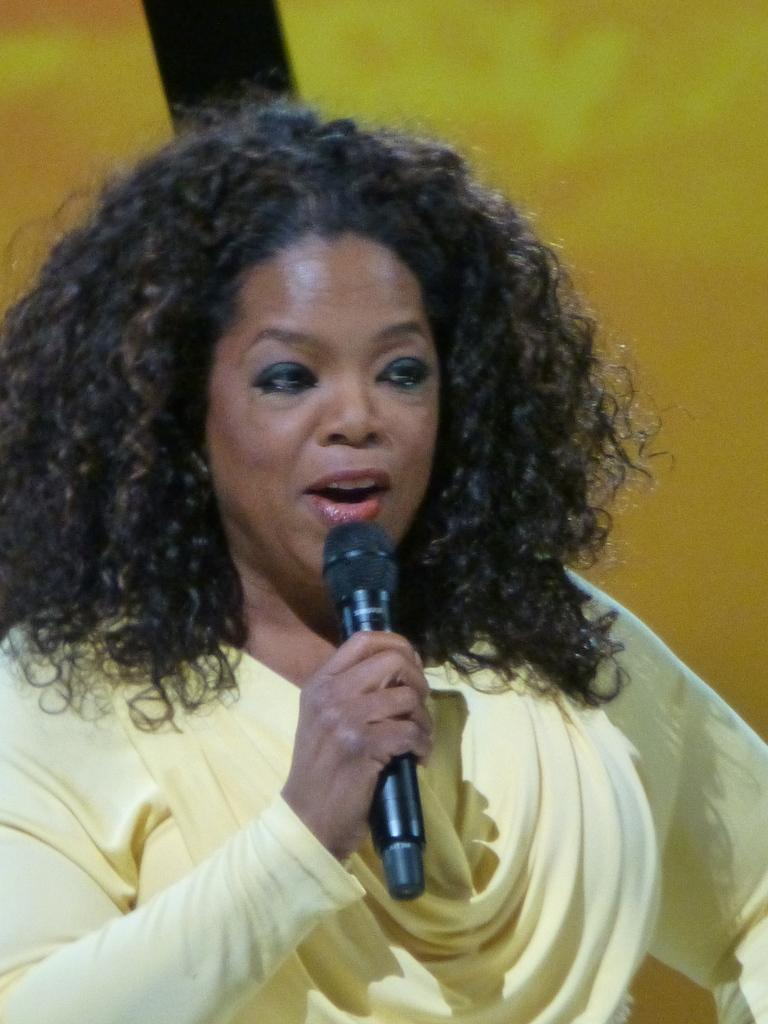What is the person holding in the image? The person is holding a microphone. What is the person doing with the microphone? The person is talking while holding the microphone. What type of cave can be seen in the background of the image? There is no cave present in the image; it only features a person holding a microphone and talking. 